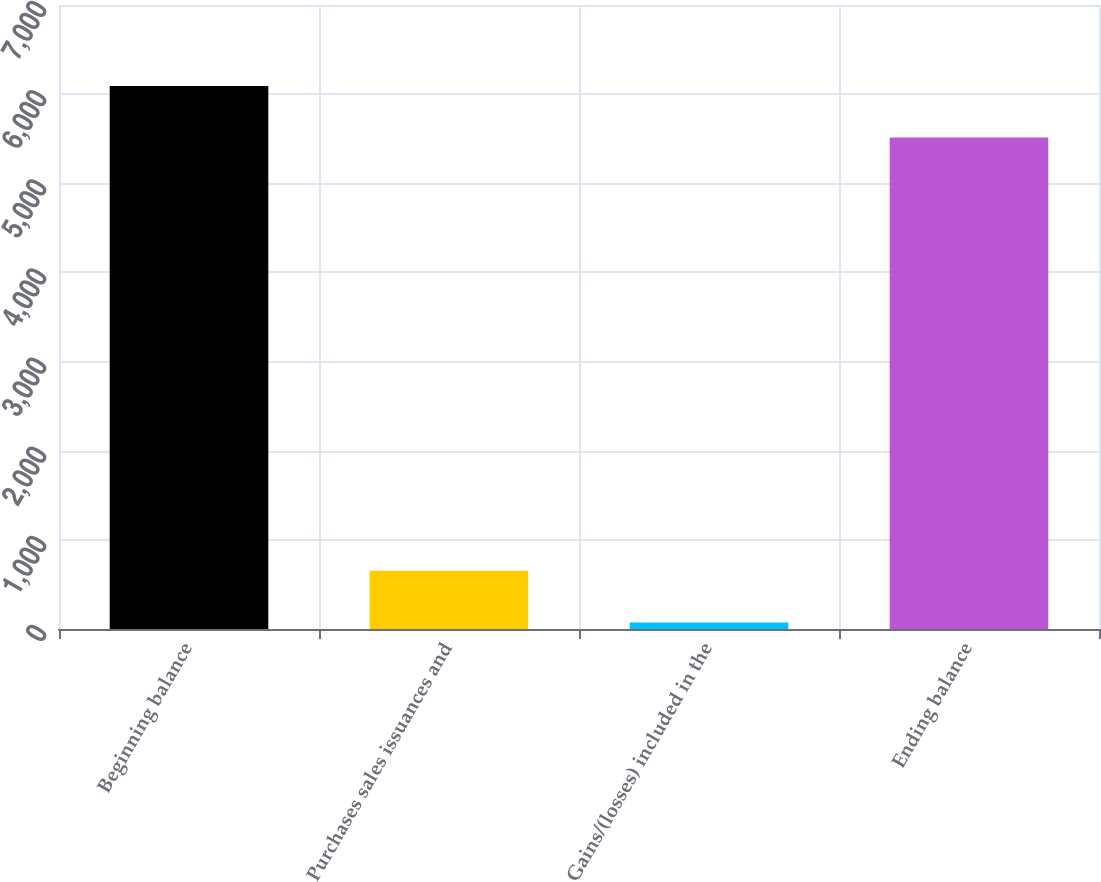Convert chart to OTSL. <chart><loc_0><loc_0><loc_500><loc_500><bar_chart><fcel>Beginning balance<fcel>Purchases sales issuances and<fcel>Gains/(losses) included in the<fcel>Ending balance<nl><fcel>6092.03<fcel>653.23<fcel>74.1<fcel>5512.9<nl></chart> 